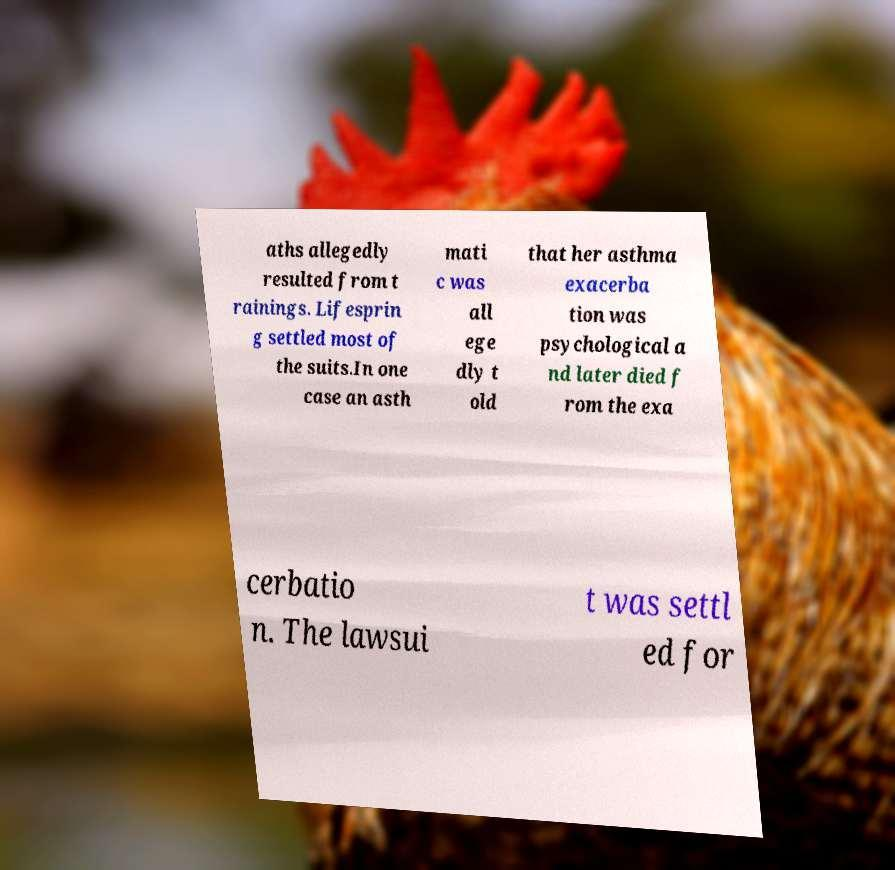I need the written content from this picture converted into text. Can you do that? aths allegedly resulted from t rainings. Lifesprin g settled most of the suits.In one case an asth mati c was all ege dly t old that her asthma exacerba tion was psychological a nd later died f rom the exa cerbatio n. The lawsui t was settl ed for 